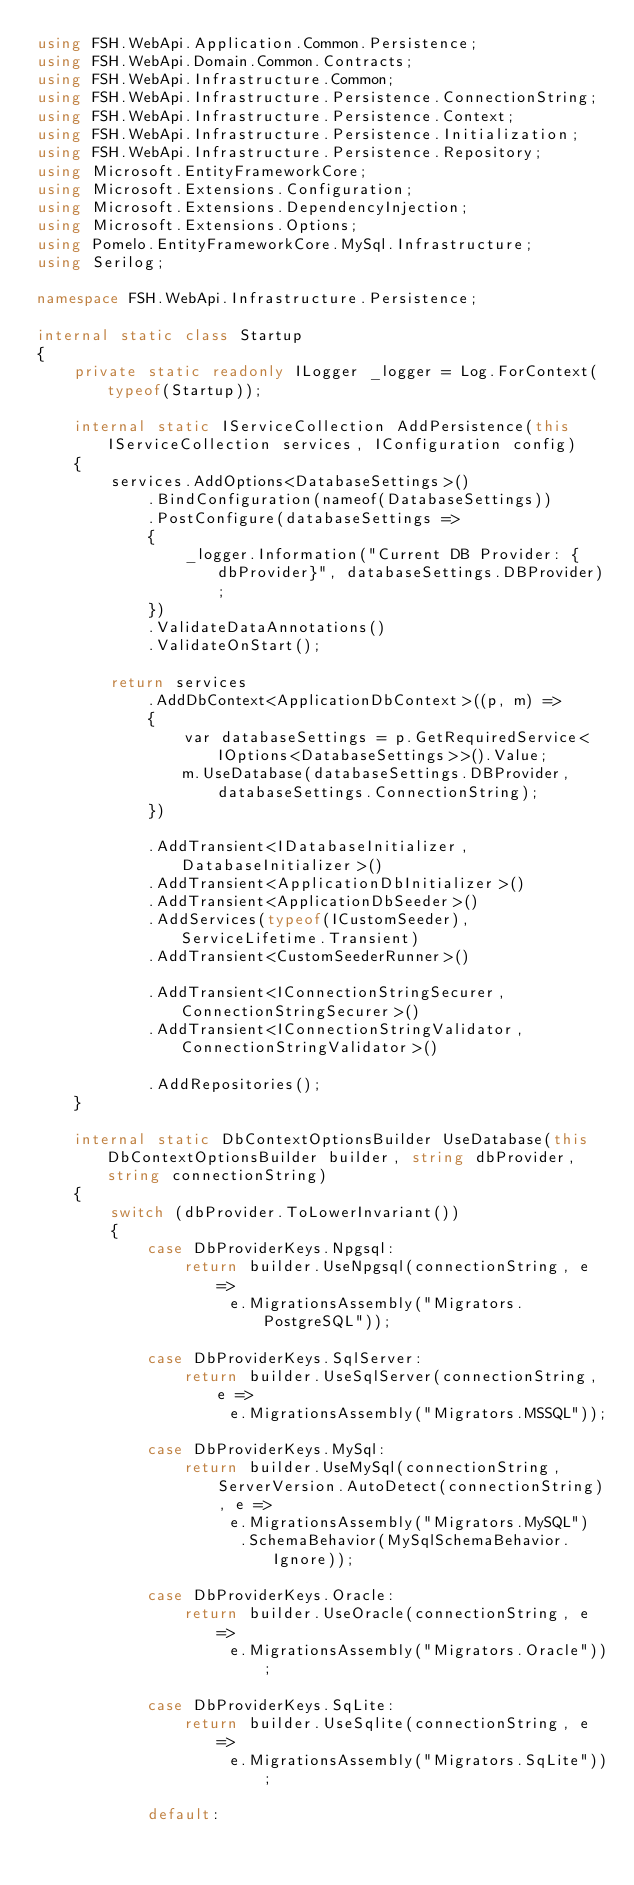<code> <loc_0><loc_0><loc_500><loc_500><_C#_>using FSH.WebApi.Application.Common.Persistence;
using FSH.WebApi.Domain.Common.Contracts;
using FSH.WebApi.Infrastructure.Common;
using FSH.WebApi.Infrastructure.Persistence.ConnectionString;
using FSH.WebApi.Infrastructure.Persistence.Context;
using FSH.WebApi.Infrastructure.Persistence.Initialization;
using FSH.WebApi.Infrastructure.Persistence.Repository;
using Microsoft.EntityFrameworkCore;
using Microsoft.Extensions.Configuration;
using Microsoft.Extensions.DependencyInjection;
using Microsoft.Extensions.Options;
using Pomelo.EntityFrameworkCore.MySql.Infrastructure;
using Serilog;

namespace FSH.WebApi.Infrastructure.Persistence;

internal static class Startup
{
    private static readonly ILogger _logger = Log.ForContext(typeof(Startup));

    internal static IServiceCollection AddPersistence(this IServiceCollection services, IConfiguration config)
    {
        services.AddOptions<DatabaseSettings>()
            .BindConfiguration(nameof(DatabaseSettings))
            .PostConfigure(databaseSettings =>
            {
                _logger.Information("Current DB Provider: {dbProvider}", databaseSettings.DBProvider);
            })
            .ValidateDataAnnotations()
            .ValidateOnStart();

        return services
            .AddDbContext<ApplicationDbContext>((p, m) =>
            {
                var databaseSettings = p.GetRequiredService<IOptions<DatabaseSettings>>().Value;
                m.UseDatabase(databaseSettings.DBProvider, databaseSettings.ConnectionString);
            })

            .AddTransient<IDatabaseInitializer, DatabaseInitializer>()
            .AddTransient<ApplicationDbInitializer>()
            .AddTransient<ApplicationDbSeeder>()
            .AddServices(typeof(ICustomSeeder), ServiceLifetime.Transient)
            .AddTransient<CustomSeederRunner>()

            .AddTransient<IConnectionStringSecurer, ConnectionStringSecurer>()
            .AddTransient<IConnectionStringValidator, ConnectionStringValidator>()

            .AddRepositories();
    }

    internal static DbContextOptionsBuilder UseDatabase(this DbContextOptionsBuilder builder, string dbProvider, string connectionString)
    {
        switch (dbProvider.ToLowerInvariant())
        {
            case DbProviderKeys.Npgsql:
                return builder.UseNpgsql(connectionString, e =>
                     e.MigrationsAssembly("Migrators.PostgreSQL"));

            case DbProviderKeys.SqlServer:
                return builder.UseSqlServer(connectionString, e =>
                     e.MigrationsAssembly("Migrators.MSSQL"));

            case DbProviderKeys.MySql:
                return builder.UseMySql(connectionString, ServerVersion.AutoDetect(connectionString), e =>
                     e.MigrationsAssembly("Migrators.MySQL")
                      .SchemaBehavior(MySqlSchemaBehavior.Ignore));

            case DbProviderKeys.Oracle:
                return builder.UseOracle(connectionString, e =>
                     e.MigrationsAssembly("Migrators.Oracle"));

            case DbProviderKeys.SqLite:
                return builder.UseSqlite(connectionString, e =>
                     e.MigrationsAssembly("Migrators.SqLite"));

            default:</code> 